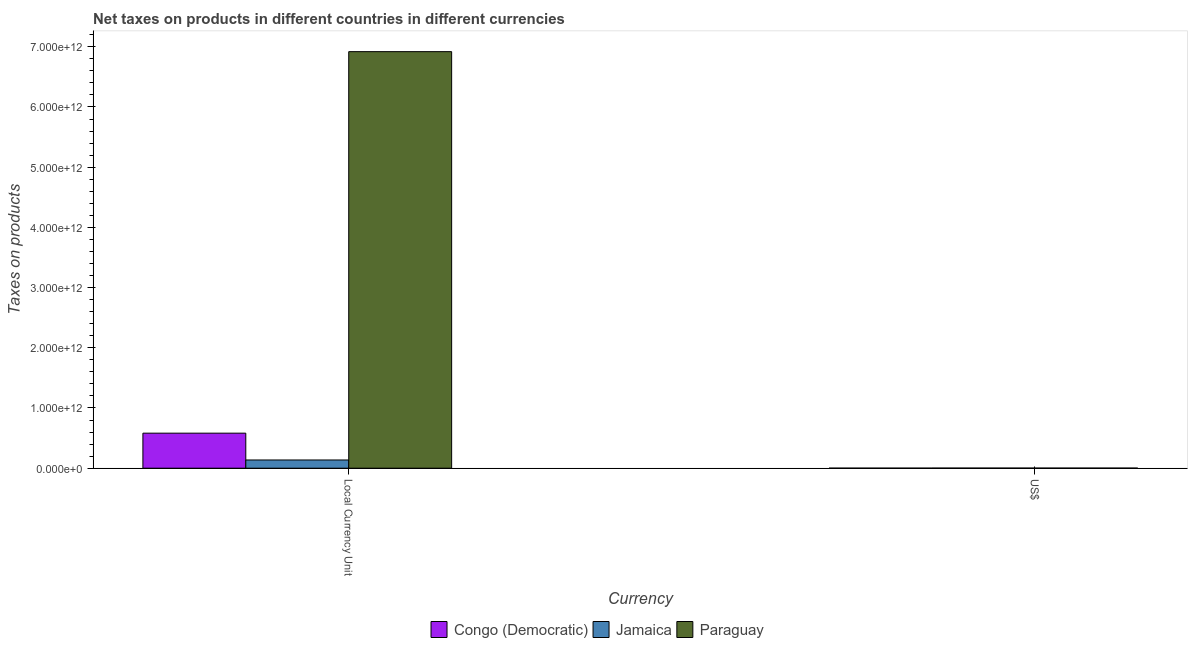How many different coloured bars are there?
Give a very brief answer. 3. How many groups of bars are there?
Your response must be concise. 2. Are the number of bars per tick equal to the number of legend labels?
Offer a terse response. Yes. How many bars are there on the 2nd tick from the right?
Your answer should be very brief. 3. What is the label of the 2nd group of bars from the left?
Make the answer very short. US$. What is the net taxes in constant 2005 us$ in Jamaica?
Give a very brief answer. 1.37e+11. Across all countries, what is the maximum net taxes in us$?
Give a very brief answer. 1.54e+09. Across all countries, what is the minimum net taxes in us$?
Make the answer very short. 7.19e+08. In which country was the net taxes in constant 2005 us$ maximum?
Your answer should be very brief. Paraguay. In which country was the net taxes in constant 2005 us$ minimum?
Provide a succinct answer. Jamaica. What is the total net taxes in constant 2005 us$ in the graph?
Make the answer very short. 7.64e+12. What is the difference between the net taxes in us$ in Jamaica and that in Paraguay?
Keep it short and to the point. 1.50e+08. What is the difference between the net taxes in constant 2005 us$ in Paraguay and the net taxes in us$ in Congo (Democratic)?
Make the answer very short. 6.92e+12. What is the average net taxes in us$ per country?
Give a very brief answer. 1.22e+09. What is the difference between the net taxes in constant 2005 us$ and net taxes in us$ in Congo (Democratic)?
Ensure brevity in your answer.  5.81e+11. In how many countries, is the net taxes in constant 2005 us$ greater than 5600000000000 units?
Your response must be concise. 1. What is the ratio of the net taxes in constant 2005 us$ in Jamaica to that in Paraguay?
Your response must be concise. 0.02. What does the 1st bar from the left in Local Currency Unit represents?
Offer a terse response. Congo (Democratic). What does the 1st bar from the right in US$ represents?
Give a very brief answer. Paraguay. How many bars are there?
Provide a succinct answer. 6. How many countries are there in the graph?
Your answer should be compact. 3. What is the difference between two consecutive major ticks on the Y-axis?
Your answer should be very brief. 1.00e+12. Does the graph contain any zero values?
Make the answer very short. No. How many legend labels are there?
Keep it short and to the point. 3. What is the title of the graph?
Offer a terse response. Net taxes on products in different countries in different currencies. Does "India" appear as one of the legend labels in the graph?
Keep it short and to the point. No. What is the label or title of the X-axis?
Provide a succinct answer. Currency. What is the label or title of the Y-axis?
Give a very brief answer. Taxes on products. What is the Taxes on products of Congo (Democratic) in Local Currency Unit?
Provide a short and direct response. 5.82e+11. What is the Taxes on products in Jamaica in Local Currency Unit?
Ensure brevity in your answer.  1.37e+11. What is the Taxes on products of Paraguay in Local Currency Unit?
Make the answer very short. 6.92e+12. What is the Taxes on products in Congo (Democratic) in US$?
Offer a terse response. 7.19e+08. What is the Taxes on products of Jamaica in US$?
Provide a short and direct response. 1.54e+09. What is the Taxes on products in Paraguay in US$?
Make the answer very short. 1.39e+09. Across all Currency, what is the maximum Taxes on products of Congo (Democratic)?
Your answer should be compact. 5.82e+11. Across all Currency, what is the maximum Taxes on products in Jamaica?
Offer a very short reply. 1.37e+11. Across all Currency, what is the maximum Taxes on products of Paraguay?
Provide a short and direct response. 6.92e+12. Across all Currency, what is the minimum Taxes on products of Congo (Democratic)?
Your response must be concise. 7.19e+08. Across all Currency, what is the minimum Taxes on products in Jamaica?
Your answer should be very brief. 1.54e+09. Across all Currency, what is the minimum Taxes on products of Paraguay?
Your answer should be very brief. 1.39e+09. What is the total Taxes on products in Congo (Democratic) in the graph?
Make the answer very short. 5.83e+11. What is the total Taxes on products in Jamaica in the graph?
Your answer should be very brief. 1.38e+11. What is the total Taxes on products of Paraguay in the graph?
Your answer should be very brief. 6.92e+12. What is the difference between the Taxes on products in Congo (Democratic) in Local Currency Unit and that in US$?
Offer a terse response. 5.81e+11. What is the difference between the Taxes on products in Jamaica in Local Currency Unit and that in US$?
Make the answer very short. 1.35e+11. What is the difference between the Taxes on products of Paraguay in Local Currency Unit and that in US$?
Offer a very short reply. 6.92e+12. What is the difference between the Taxes on products in Congo (Democratic) in Local Currency Unit and the Taxes on products in Jamaica in US$?
Provide a short and direct response. 5.80e+11. What is the difference between the Taxes on products of Congo (Democratic) in Local Currency Unit and the Taxes on products of Paraguay in US$?
Offer a terse response. 5.81e+11. What is the difference between the Taxes on products in Jamaica in Local Currency Unit and the Taxes on products in Paraguay in US$?
Offer a very short reply. 1.35e+11. What is the average Taxes on products of Congo (Democratic) per Currency?
Offer a terse response. 2.91e+11. What is the average Taxes on products in Jamaica per Currency?
Provide a succinct answer. 6.90e+1. What is the average Taxes on products of Paraguay per Currency?
Keep it short and to the point. 3.46e+12. What is the difference between the Taxes on products of Congo (Democratic) and Taxes on products of Jamaica in Local Currency Unit?
Offer a terse response. 4.45e+11. What is the difference between the Taxes on products in Congo (Democratic) and Taxes on products in Paraguay in Local Currency Unit?
Keep it short and to the point. -6.34e+12. What is the difference between the Taxes on products in Jamaica and Taxes on products in Paraguay in Local Currency Unit?
Your response must be concise. -6.78e+12. What is the difference between the Taxes on products of Congo (Democratic) and Taxes on products of Jamaica in US$?
Your answer should be very brief. -8.24e+08. What is the difference between the Taxes on products in Congo (Democratic) and Taxes on products in Paraguay in US$?
Your response must be concise. -6.75e+08. What is the difference between the Taxes on products in Jamaica and Taxes on products in Paraguay in US$?
Provide a short and direct response. 1.50e+08. What is the ratio of the Taxes on products of Congo (Democratic) in Local Currency Unit to that in US$?
Make the answer very short. 809.79. What is the ratio of the Taxes on products of Jamaica in Local Currency Unit to that in US$?
Your answer should be compact. 88.49. What is the ratio of the Taxes on products of Paraguay in Local Currency Unit to that in US$?
Offer a very short reply. 4966.58. What is the difference between the highest and the second highest Taxes on products in Congo (Democratic)?
Offer a terse response. 5.81e+11. What is the difference between the highest and the second highest Taxes on products of Jamaica?
Provide a succinct answer. 1.35e+11. What is the difference between the highest and the second highest Taxes on products in Paraguay?
Provide a succinct answer. 6.92e+12. What is the difference between the highest and the lowest Taxes on products of Congo (Democratic)?
Provide a succinct answer. 5.81e+11. What is the difference between the highest and the lowest Taxes on products of Jamaica?
Give a very brief answer. 1.35e+11. What is the difference between the highest and the lowest Taxes on products of Paraguay?
Offer a very short reply. 6.92e+12. 